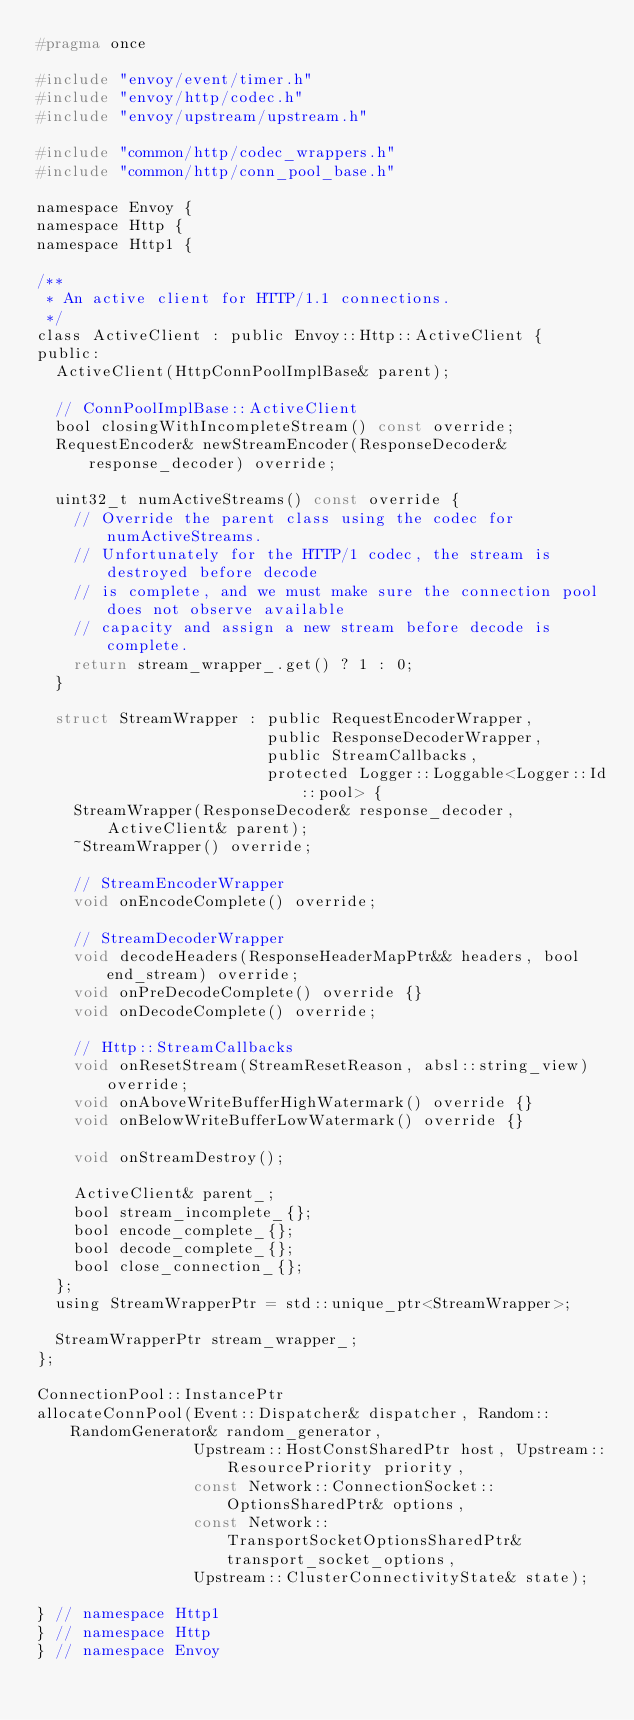<code> <loc_0><loc_0><loc_500><loc_500><_C_>#pragma once

#include "envoy/event/timer.h"
#include "envoy/http/codec.h"
#include "envoy/upstream/upstream.h"

#include "common/http/codec_wrappers.h"
#include "common/http/conn_pool_base.h"

namespace Envoy {
namespace Http {
namespace Http1 {

/**
 * An active client for HTTP/1.1 connections.
 */
class ActiveClient : public Envoy::Http::ActiveClient {
public:
  ActiveClient(HttpConnPoolImplBase& parent);

  // ConnPoolImplBase::ActiveClient
  bool closingWithIncompleteStream() const override;
  RequestEncoder& newStreamEncoder(ResponseDecoder& response_decoder) override;

  uint32_t numActiveStreams() const override {
    // Override the parent class using the codec for numActiveStreams.
    // Unfortunately for the HTTP/1 codec, the stream is destroyed before decode
    // is complete, and we must make sure the connection pool does not observe available
    // capacity and assign a new stream before decode is complete.
    return stream_wrapper_.get() ? 1 : 0;
  }

  struct StreamWrapper : public RequestEncoderWrapper,
                         public ResponseDecoderWrapper,
                         public StreamCallbacks,
                         protected Logger::Loggable<Logger::Id::pool> {
    StreamWrapper(ResponseDecoder& response_decoder, ActiveClient& parent);
    ~StreamWrapper() override;

    // StreamEncoderWrapper
    void onEncodeComplete() override;

    // StreamDecoderWrapper
    void decodeHeaders(ResponseHeaderMapPtr&& headers, bool end_stream) override;
    void onPreDecodeComplete() override {}
    void onDecodeComplete() override;

    // Http::StreamCallbacks
    void onResetStream(StreamResetReason, absl::string_view) override;
    void onAboveWriteBufferHighWatermark() override {}
    void onBelowWriteBufferLowWatermark() override {}

    void onStreamDestroy();

    ActiveClient& parent_;
    bool stream_incomplete_{};
    bool encode_complete_{};
    bool decode_complete_{};
    bool close_connection_{};
  };
  using StreamWrapperPtr = std::unique_ptr<StreamWrapper>;

  StreamWrapperPtr stream_wrapper_;
};

ConnectionPool::InstancePtr
allocateConnPool(Event::Dispatcher& dispatcher, Random::RandomGenerator& random_generator,
                 Upstream::HostConstSharedPtr host, Upstream::ResourcePriority priority,
                 const Network::ConnectionSocket::OptionsSharedPtr& options,
                 const Network::TransportSocketOptionsSharedPtr& transport_socket_options,
                 Upstream::ClusterConnectivityState& state);

} // namespace Http1
} // namespace Http
} // namespace Envoy
</code> 